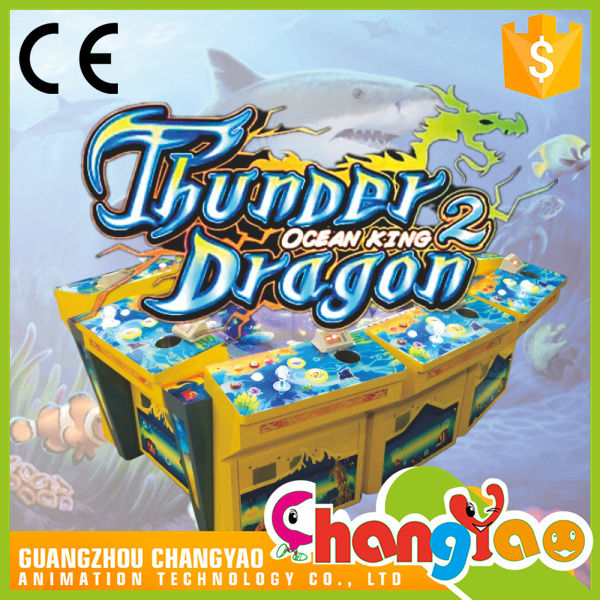Can you describe the atmosphere this game is designed to create for its players? Certainly! The 'Thunder Dragon 2 Ocean King' arcade game is engineered to immerse players in an exhilarating underwater realm. Ambient sounds of the ocean and themed music likely accompany the eye-catching, marine visuals to enhance the user's experience. The bright, flashy graphics, with vivid depictions of sea life and mythical creatures, together with the fierce competition to catch or vanquish the ocean dwellers, would generate an atmosphere of high energy and camaraderie among players. The shared excitement of trying to outscore friends in this aquatic hunting quest creates a thrilling social gaming environment. 